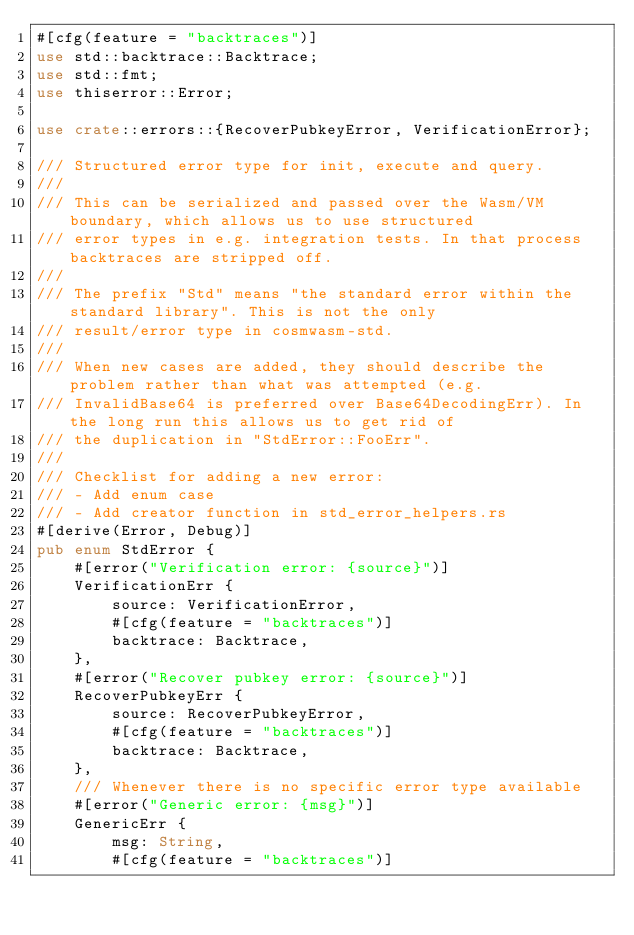<code> <loc_0><loc_0><loc_500><loc_500><_Rust_>#[cfg(feature = "backtraces")]
use std::backtrace::Backtrace;
use std::fmt;
use thiserror::Error;

use crate::errors::{RecoverPubkeyError, VerificationError};

/// Structured error type for init, execute and query.
///
/// This can be serialized and passed over the Wasm/VM boundary, which allows us to use structured
/// error types in e.g. integration tests. In that process backtraces are stripped off.
///
/// The prefix "Std" means "the standard error within the standard library". This is not the only
/// result/error type in cosmwasm-std.
///
/// When new cases are added, they should describe the problem rather than what was attempted (e.g.
/// InvalidBase64 is preferred over Base64DecodingErr). In the long run this allows us to get rid of
/// the duplication in "StdError::FooErr".
///
/// Checklist for adding a new error:
/// - Add enum case
/// - Add creator function in std_error_helpers.rs
#[derive(Error, Debug)]
pub enum StdError {
    #[error("Verification error: {source}")]
    VerificationErr {
        source: VerificationError,
        #[cfg(feature = "backtraces")]
        backtrace: Backtrace,
    },
    #[error("Recover pubkey error: {source}")]
    RecoverPubkeyErr {
        source: RecoverPubkeyError,
        #[cfg(feature = "backtraces")]
        backtrace: Backtrace,
    },
    /// Whenever there is no specific error type available
    #[error("Generic error: {msg}")]
    GenericErr {
        msg: String,
        #[cfg(feature = "backtraces")]</code> 